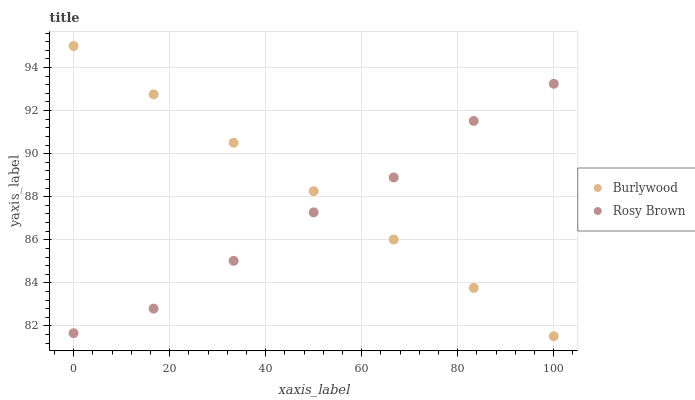Does Rosy Brown have the minimum area under the curve?
Answer yes or no. Yes. Does Burlywood have the maximum area under the curve?
Answer yes or no. Yes. Does Rosy Brown have the maximum area under the curve?
Answer yes or no. No. Is Burlywood the smoothest?
Answer yes or no. Yes. Is Rosy Brown the roughest?
Answer yes or no. Yes. Is Rosy Brown the smoothest?
Answer yes or no. No. Does Burlywood have the lowest value?
Answer yes or no. Yes. Does Rosy Brown have the lowest value?
Answer yes or no. No. Does Burlywood have the highest value?
Answer yes or no. Yes. Does Rosy Brown have the highest value?
Answer yes or no. No. Does Burlywood intersect Rosy Brown?
Answer yes or no. Yes. Is Burlywood less than Rosy Brown?
Answer yes or no. No. Is Burlywood greater than Rosy Brown?
Answer yes or no. No. 